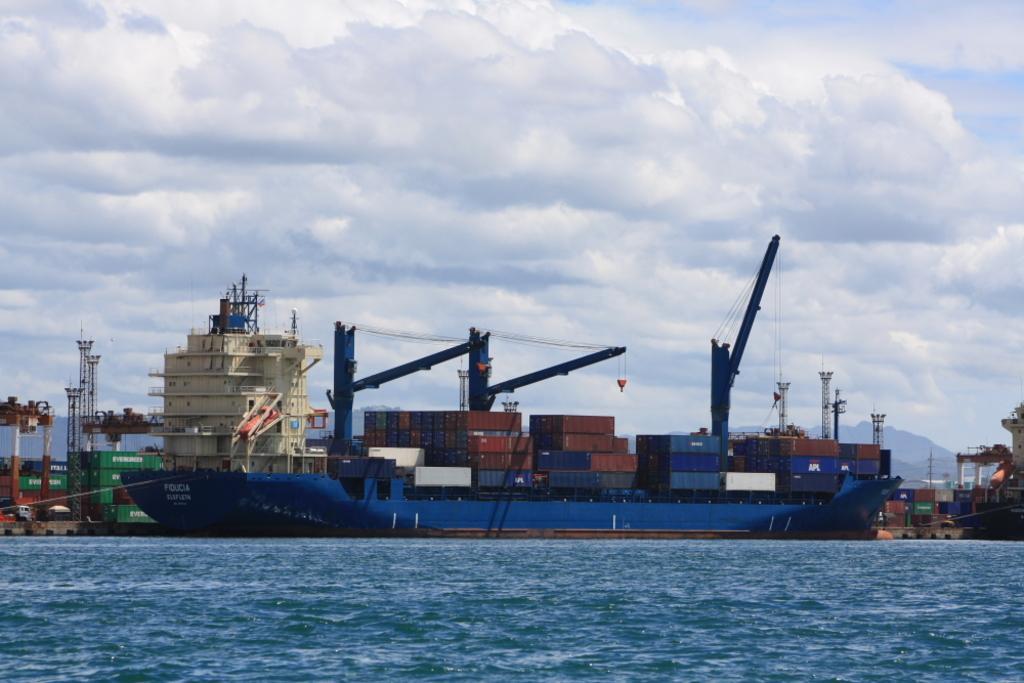Can you describe this image briefly? In this image we can see ship on the water and there are some containers, rods with wires, a building and sky in the background. 